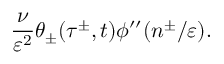<formula> <loc_0><loc_0><loc_500><loc_500>\frac { \nu } { \varepsilon ^ { 2 } } \theta _ { \pm } ( \tau ^ { \pm } , t ) \phi ^ { \prime \prime } ( n ^ { \pm } / \varepsilon ) .</formula> 